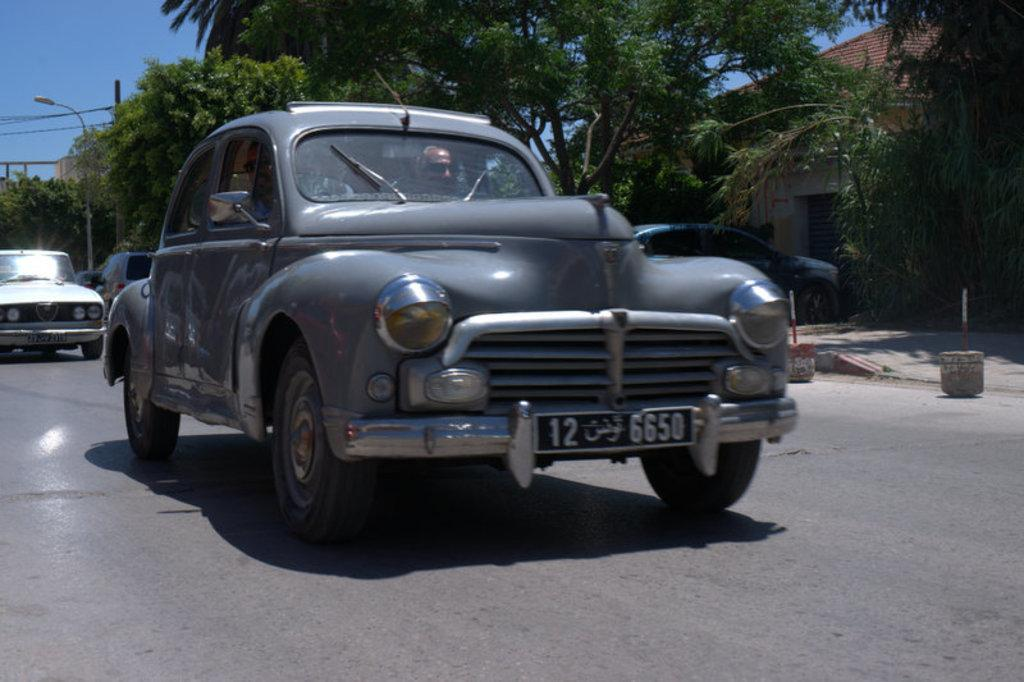What type of vehicles can be seen on the road in the image? There are cars on the road in the image. What structures are visible in the image? There are buildings in the image. What type of vegetation is present in the image? Trees are present in the image. What type of lighting is visible in the image? There is a pole light in the image. What is the color of the sky in the image? The sky is blue in the image. How many questions are being asked in the image? There are no questions visible in the image; it is a still image of a scene. Can you tell me how the person in the image is providing help? There is no person visible in the image, and therefore no indication of someone providing help. 